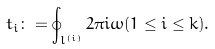Convert formula to latex. <formula><loc_0><loc_0><loc_500><loc_500>t _ { i } \colon = \oint _ { l ^ { ( i ) } } 2 \pi i \omega ( 1 \leq i \leq k ) .</formula> 